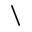Convert formula to latex. <formula><loc_0><loc_0><loc_500><loc_500>\</formula> 